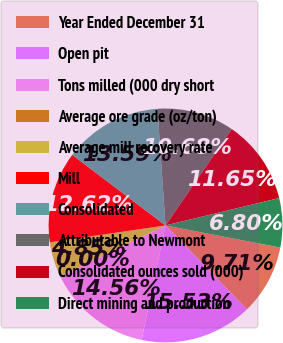Convert chart. <chart><loc_0><loc_0><loc_500><loc_500><pie_chart><fcel>Year Ended December 31<fcel>Open pit<fcel>Tons milled (000 dry short<fcel>Average ore grade (oz/ton)<fcel>Average mill recovery rate<fcel>Mill<fcel>Consolidated<fcel>Attributable to Newmont<fcel>Consolidated ounces sold (000)<fcel>Direct mining and production<nl><fcel>9.71%<fcel>15.53%<fcel>14.56%<fcel>0.0%<fcel>4.85%<fcel>12.62%<fcel>13.59%<fcel>10.68%<fcel>11.65%<fcel>6.8%<nl></chart> 